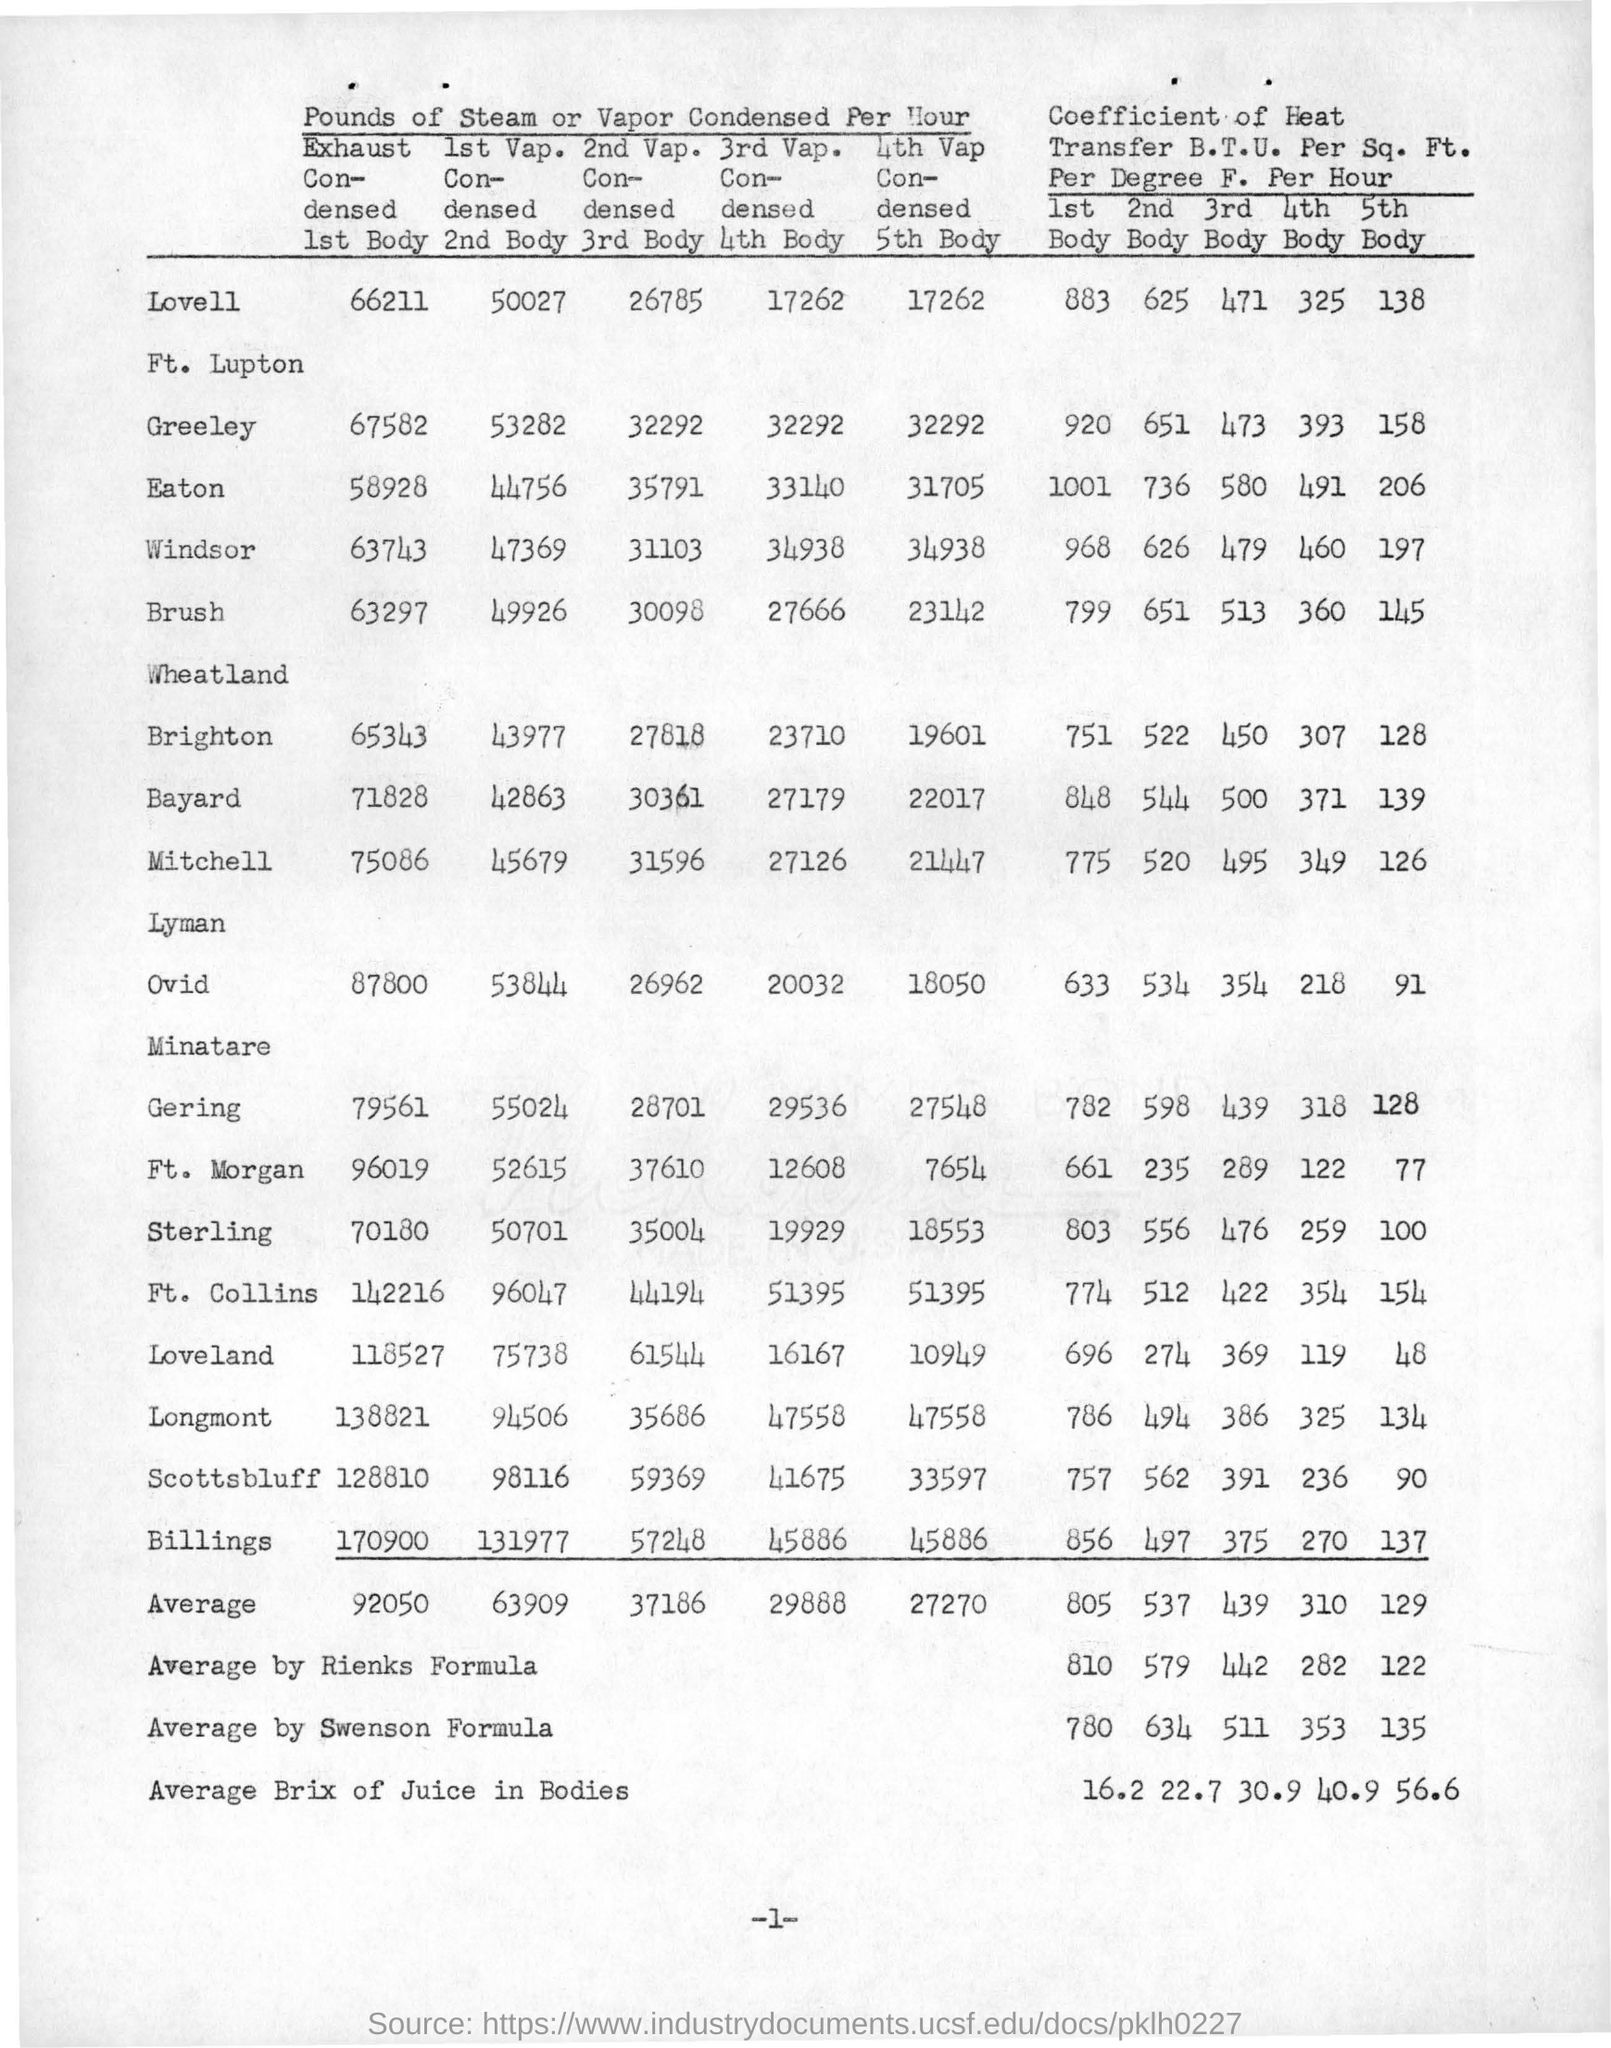what is the value of average by swenson formula for the coefficient of heat in 5th body ? Based on the data provided in the image, the average value for the coefficient of heat transfer (B.T.U. per Sq. Ft. per Degree F. per Hour) for the 5th body, as calculated by the Swenson formula, is 135. This figure is deduced from a table listing the values for several locations, and it corresponds to an average taken from distinct condensing body data points. It is essential to interpret this data within the context of the full table, which compares various condensing bodies and their heat transfer coefficients, showing variations that might indicate different efficiencies or operational conditions. 